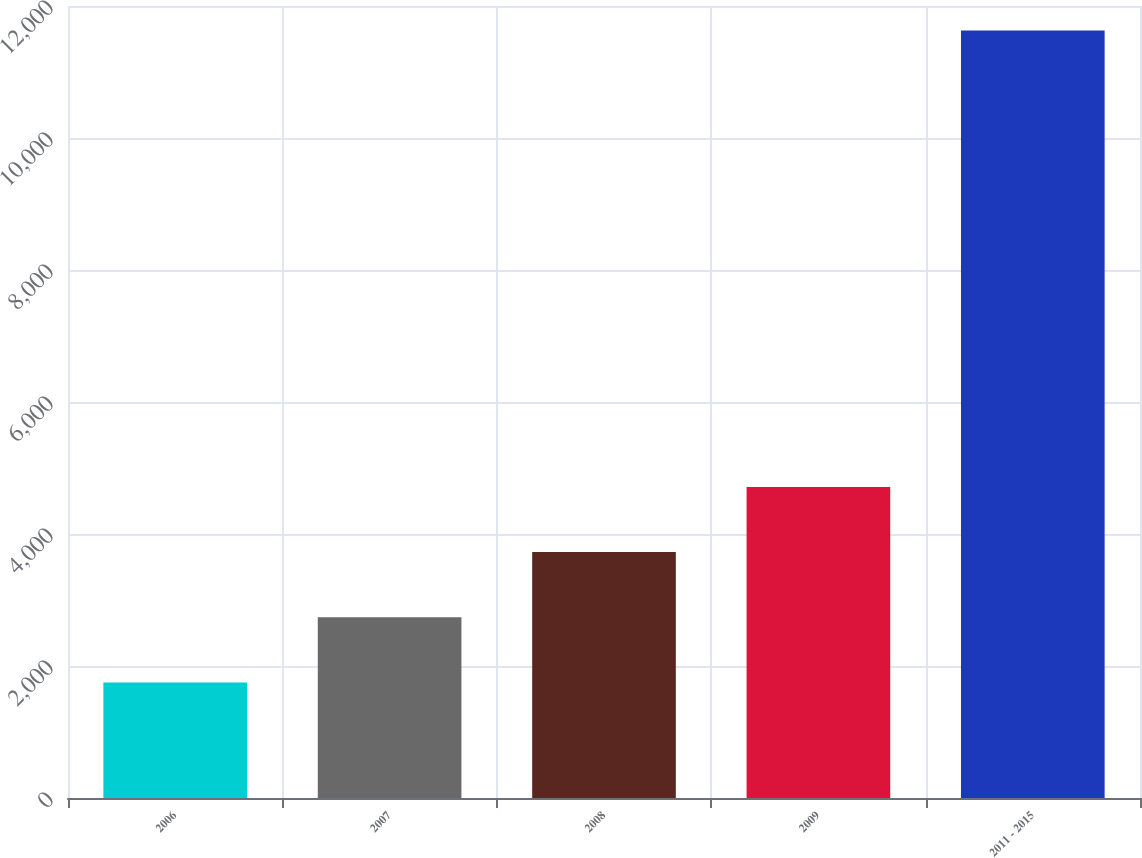Convert chart. <chart><loc_0><loc_0><loc_500><loc_500><bar_chart><fcel>2006<fcel>2007<fcel>2008<fcel>2009<fcel>2011 - 2015<nl><fcel>1750<fcel>2738<fcel>3726<fcel>4714<fcel>11630<nl></chart> 